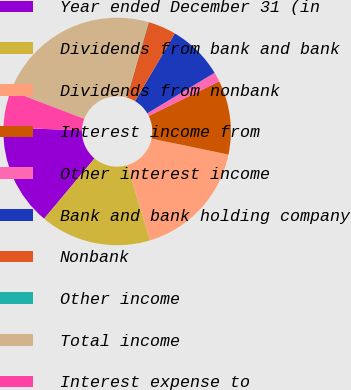<chart> <loc_0><loc_0><loc_500><loc_500><pie_chart><fcel>Year ended December 31 (in<fcel>Dividends from bank and bank<fcel>Dividends from nonbank<fcel>Interest income from<fcel>Other interest income<fcel>Bank and bank holding company<fcel>Nonbank<fcel>Other income<fcel>Total income<fcel>Interest expense to<nl><fcel>14.45%<fcel>15.76%<fcel>17.07%<fcel>10.52%<fcel>1.36%<fcel>7.9%<fcel>3.98%<fcel>0.05%<fcel>23.62%<fcel>5.28%<nl></chart> 